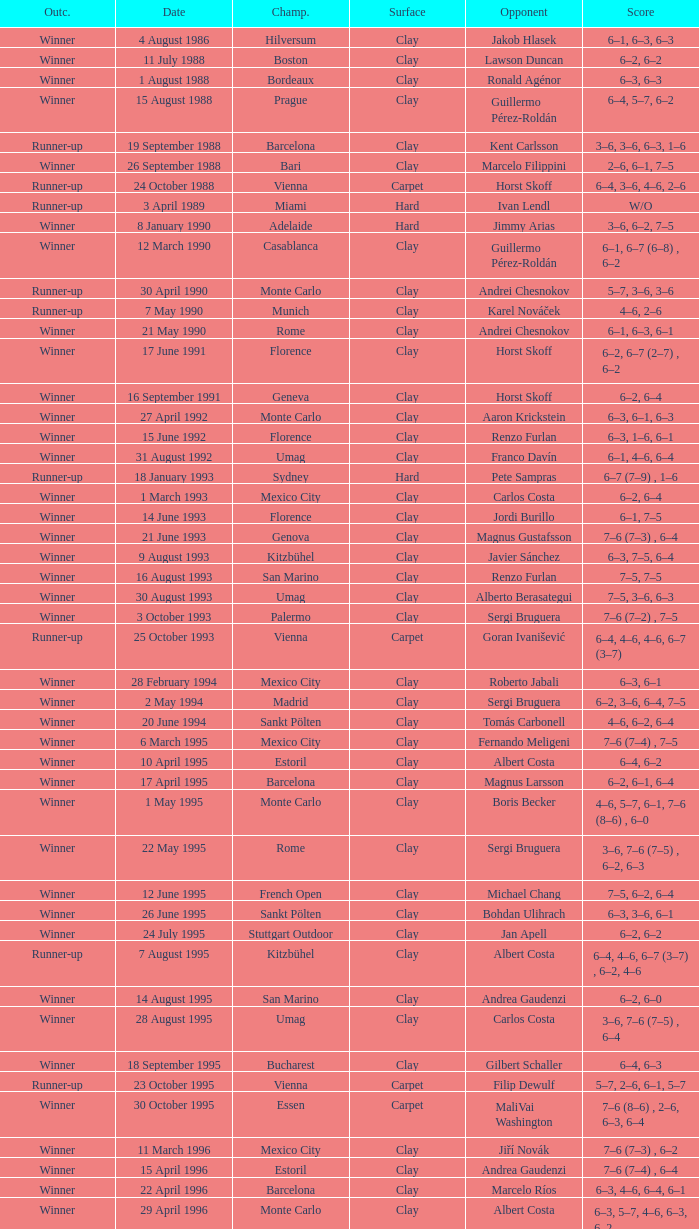Who is the opponent on 18 january 1993? Pete Sampras. 